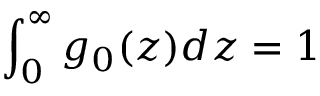<formula> <loc_0><loc_0><loc_500><loc_500>\int _ { 0 } ^ { \infty } g _ { 0 } ( z ) d z = 1</formula> 